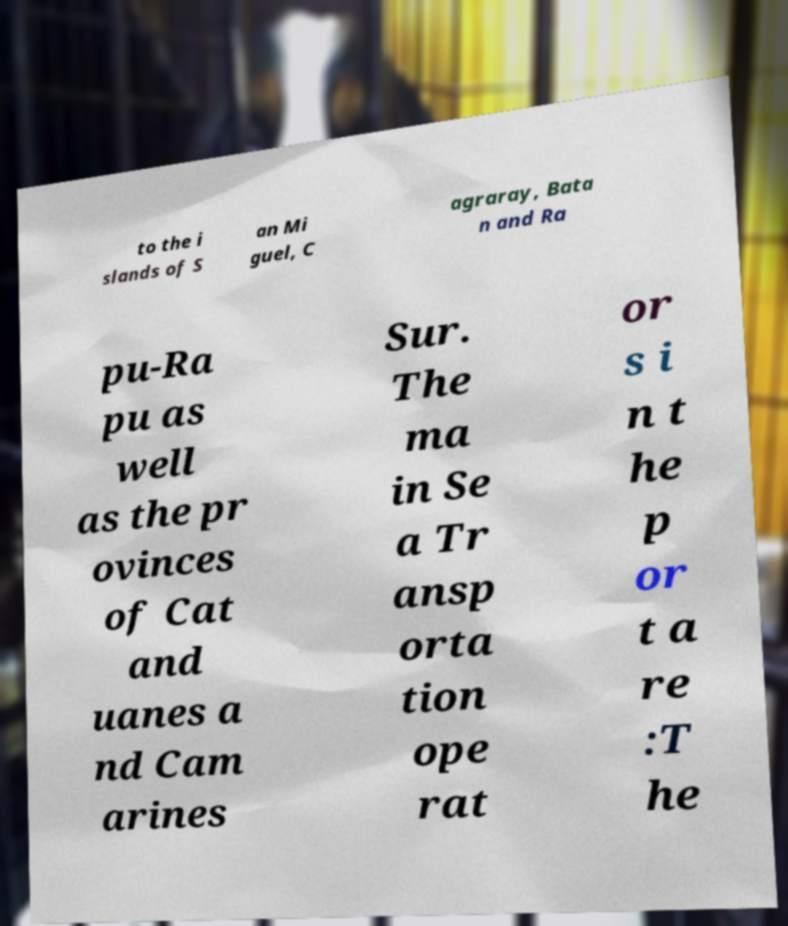Please identify and transcribe the text found in this image. to the i slands of S an Mi guel, C agraray, Bata n and Ra pu-Ra pu as well as the pr ovinces of Cat and uanes a nd Cam arines Sur. The ma in Se a Tr ansp orta tion ope rat or s i n t he p or t a re :T he 